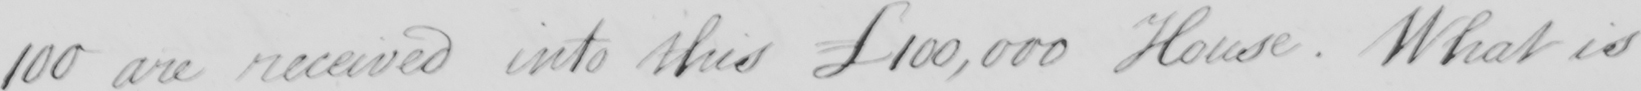Please transcribe the handwritten text in this image. 100 are received into this £100,000 House. What is 